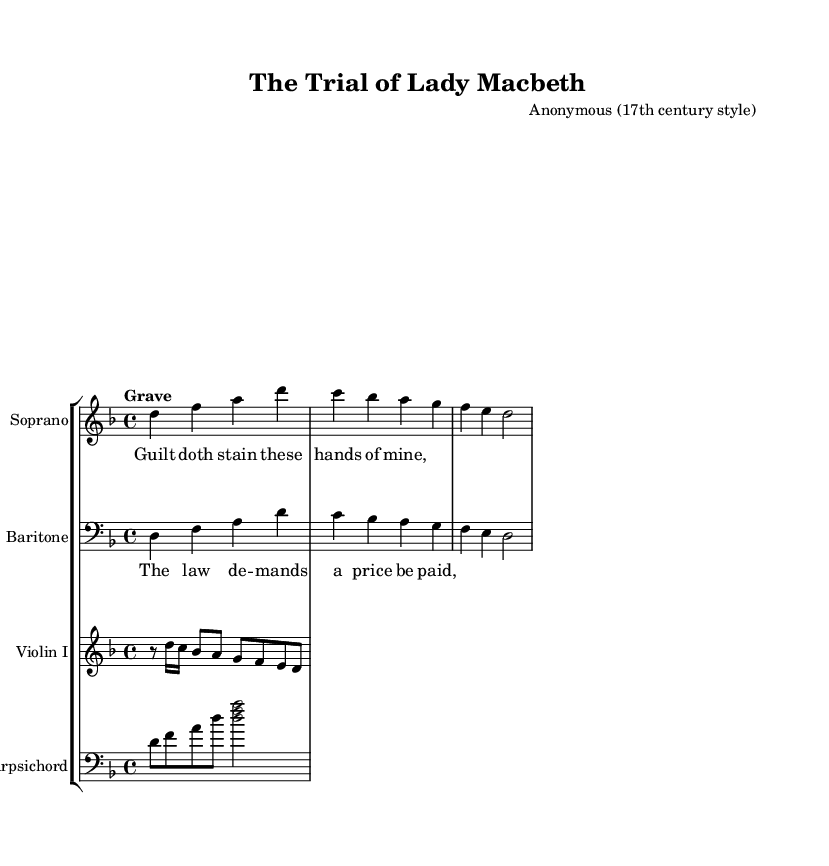What is the key signature of this music? The key signature is D minor, indicated by one flat (B♭) on the staff.
Answer: D minor What is the time signature of this music? The time signature is 4/4, shown at the beginning of the sheet music as a fraction, indicating four beats per measure.
Answer: 4/4 What is the tempo marking for this piece? The tempo marking is "Grave," which means a very slow tempo, guiding performers on the speed of the music.
Answer: Grave How many measures are in the soprano part? There are three measures in the soprano part, as indicated by the grouping of notes in the score.
Answer: Three measures What is the main theme expressed in the soprano's lyrics? The lyrics express guilt, specifically through the phrase "Guilt doth stain these hands of mine," indicating the psychological burden on the character.
Answer: Guilt What type of ensemble is performing this piece? The ensemble consists of a soprano, baritone, violin, and harpsichord, which is characteristic of Baroque operatic works.
Answer: Vocal and instrumental ensemble How does the harpsichord contribute to the texture of this piece? The harpsichord provides harmonic support and adds a distinct timbre typical of Baroque music, enhancing the overall sound texture.
Answer: Harmonic support 